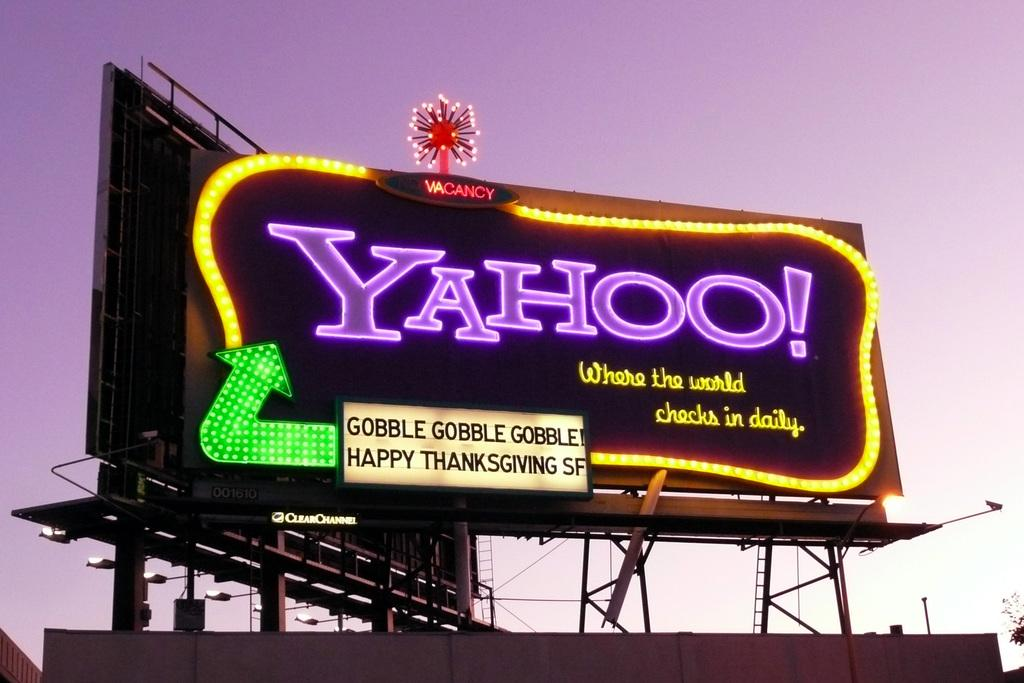<image>
Offer a succinct explanation of the picture presented. A billboard for Yahoo! wishes SF a Happy Thanksgiving. 